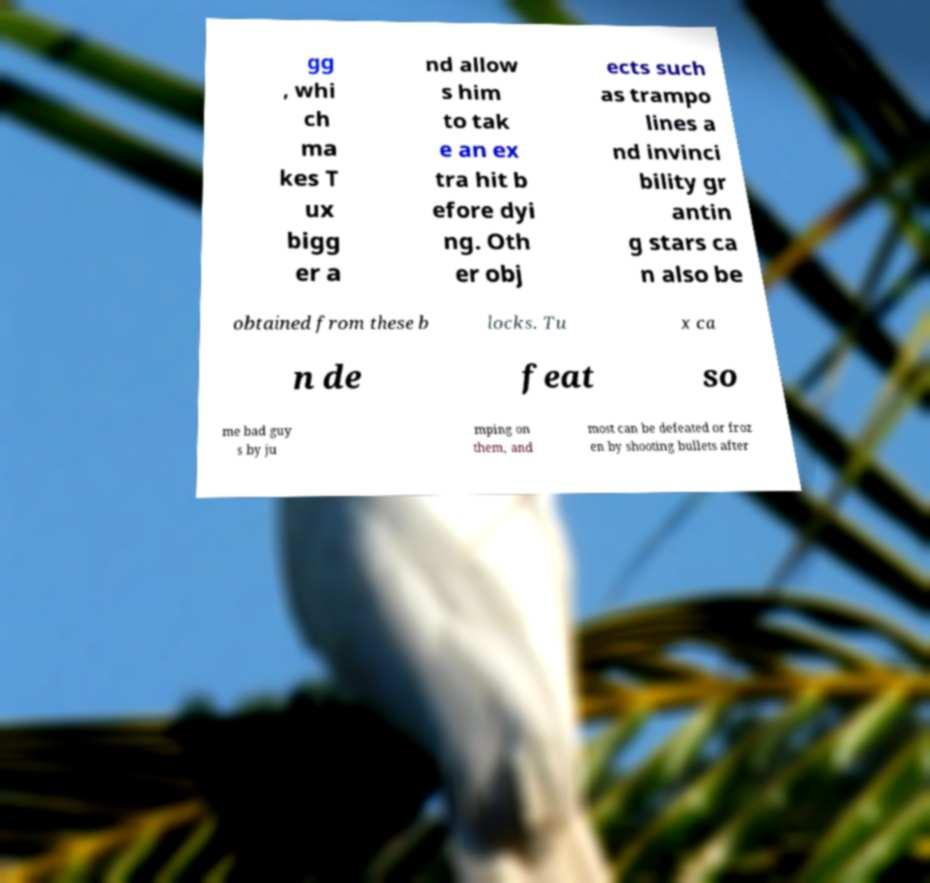Could you extract and type out the text from this image? gg , whi ch ma kes T ux bigg er a nd allow s him to tak e an ex tra hit b efore dyi ng. Oth er obj ects such as trampo lines a nd invinci bility gr antin g stars ca n also be obtained from these b locks. Tu x ca n de feat so me bad guy s by ju mping on them, and most can be defeated or froz en by shooting bullets after 